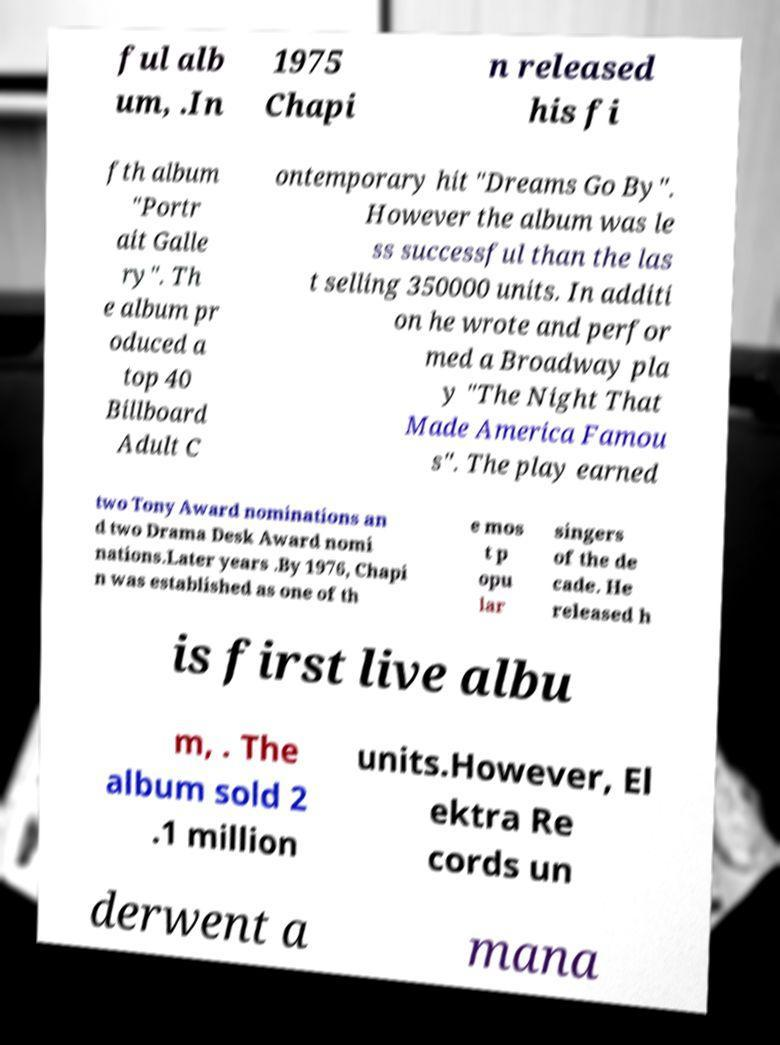Could you extract and type out the text from this image? ful alb um, .In 1975 Chapi n released his fi fth album "Portr ait Galle ry". Th e album pr oduced a top 40 Billboard Adult C ontemporary hit "Dreams Go By". However the album was le ss successful than the las t selling 350000 units. In additi on he wrote and perfor med a Broadway pla y "The Night That Made America Famou s". The play earned two Tony Award nominations an d two Drama Desk Award nomi nations.Later years .By 1976, Chapi n was established as one of th e mos t p opu lar singers of the de cade. He released h is first live albu m, . The album sold 2 .1 million units.However, El ektra Re cords un derwent a mana 